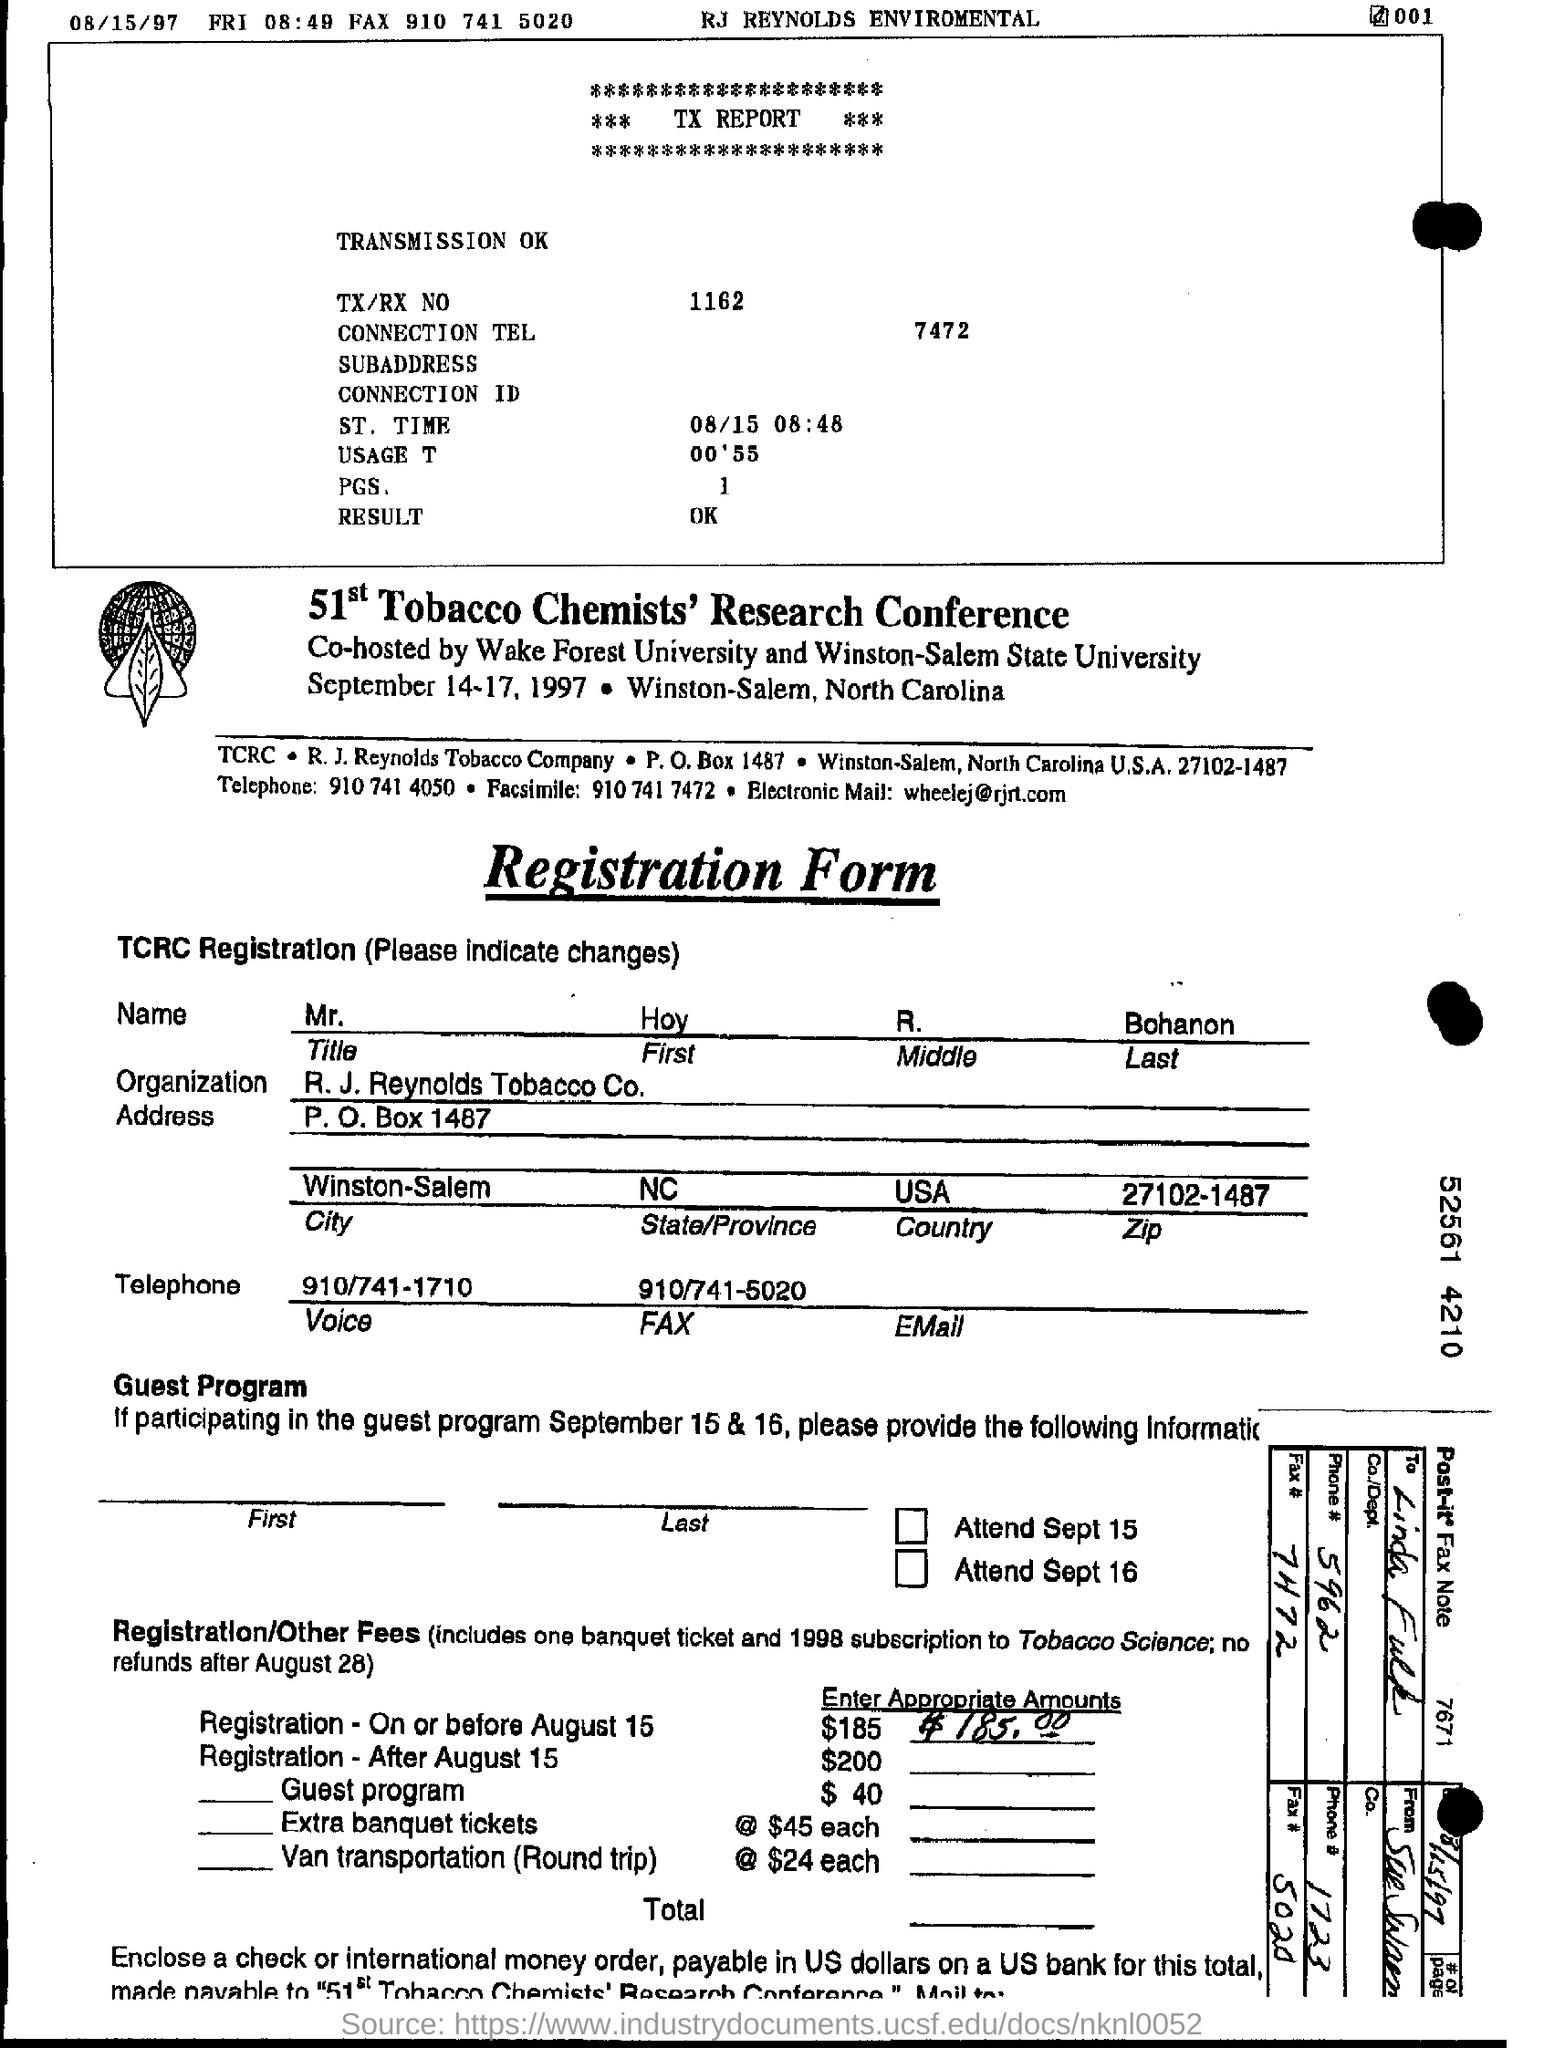Point out several critical features in this image. What is the City? Winston-Salem, North Carolina, is an example of a thriving urban center. R.J. Reynolds Tobacco Company is an organization that is in question. The result is OK. What is the ZIP code? 27102-1487... The text "What is the TX/RX No.? 1162.." is incomplete and does not convey a clear message. It is unclear what the text is asking or what the context is. In order to provide a clear and accurate response, more information is needed. 